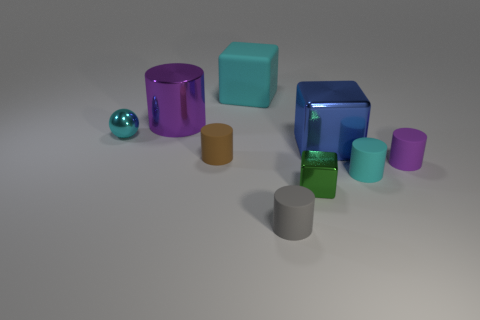Is there a pattern in how the objects are arranged? The arrangement of the objects does not follow a strict pattern, but they are evenly spaced and spread across the surface, which could suggest a deliberate placement, possibly to showcase their colors and shapes. Could there be a reason for this particular arrangement? If this is a rendered scene, the objects may have been arranged to create a visually pleasing composition or to demonstrate different geometric forms and how they interact with light. In a more practical context, such as a product display, the arrangement might be aimed at highlighting individual features or simply ensuring that each item is clearly visible. 